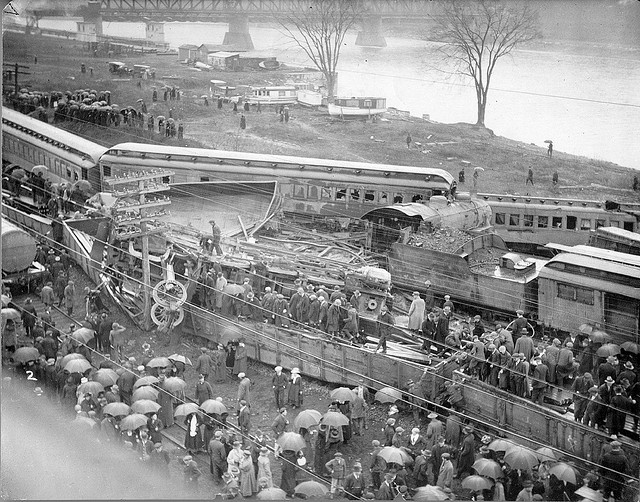Describe the objects in this image and their specific colors. I can see people in gray, darkgray, black, and lightgray tones, train in gray, darkgray, lightgray, and black tones, train in gray, darkgray, black, and lightgray tones, umbrella in gray, darkgray, lightgray, and black tones, and train in gray, black, and lightgray tones in this image. 